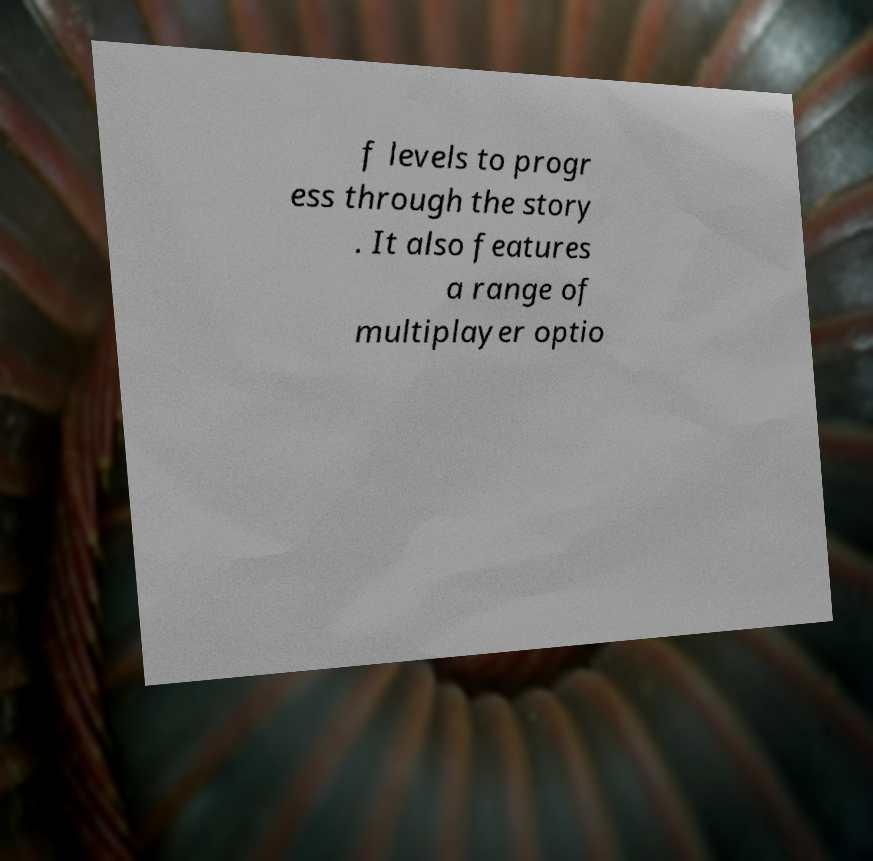Can you accurately transcribe the text from the provided image for me? f levels to progr ess through the story . It also features a range of multiplayer optio 